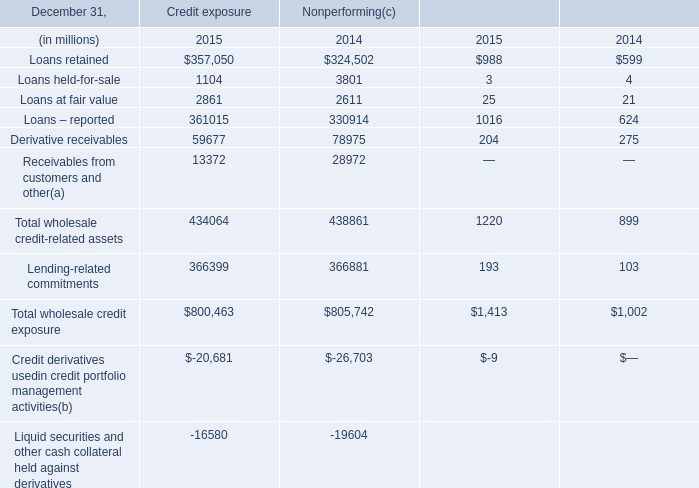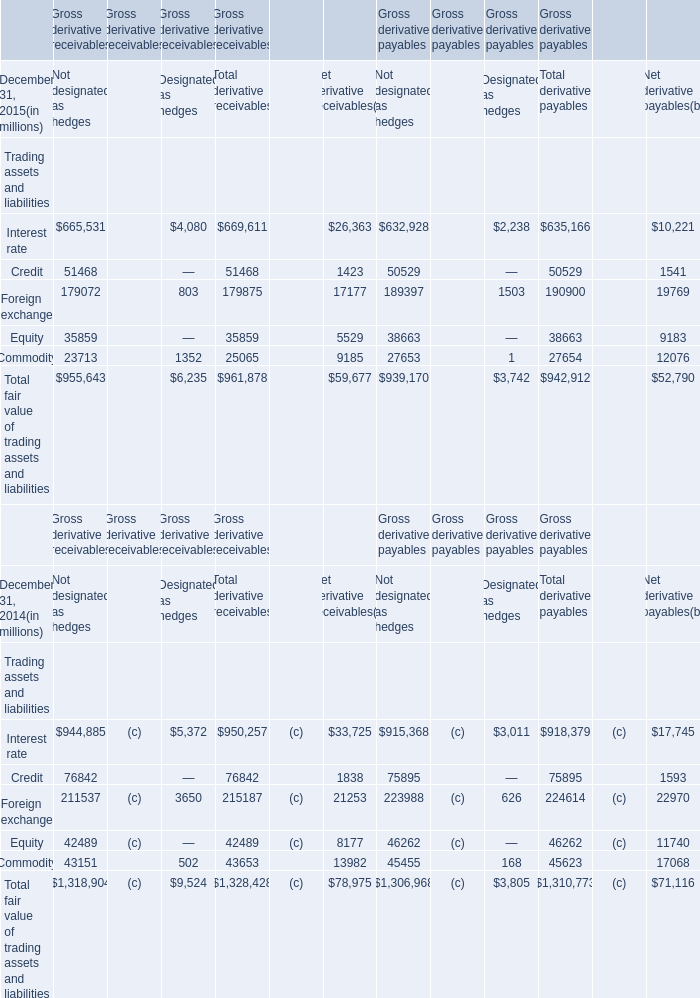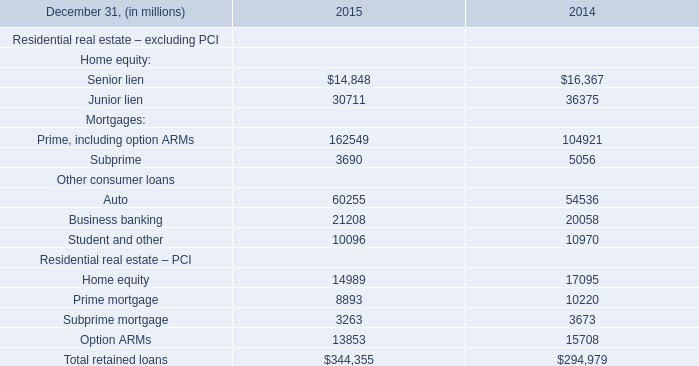What is the total amount of Interest rate of Gross derivative payables Not designated as hedges, Junior lien of 2015, and Foreign exchange of Gross derivative payables Net derivative payables ? 
Computations: ((632928.0 + 30711.0) + 19769.0)
Answer: 683408.0. 